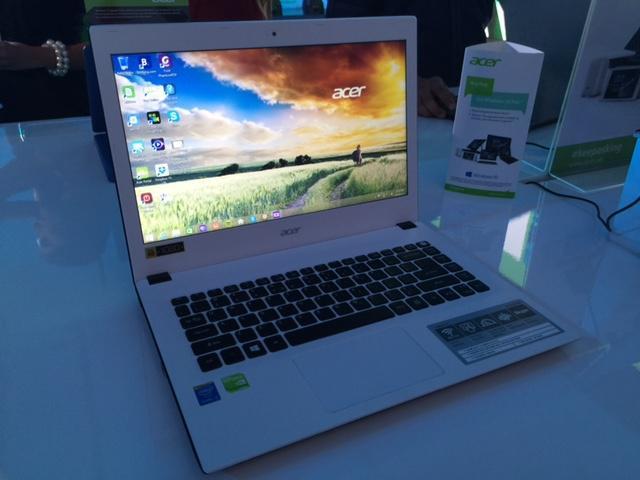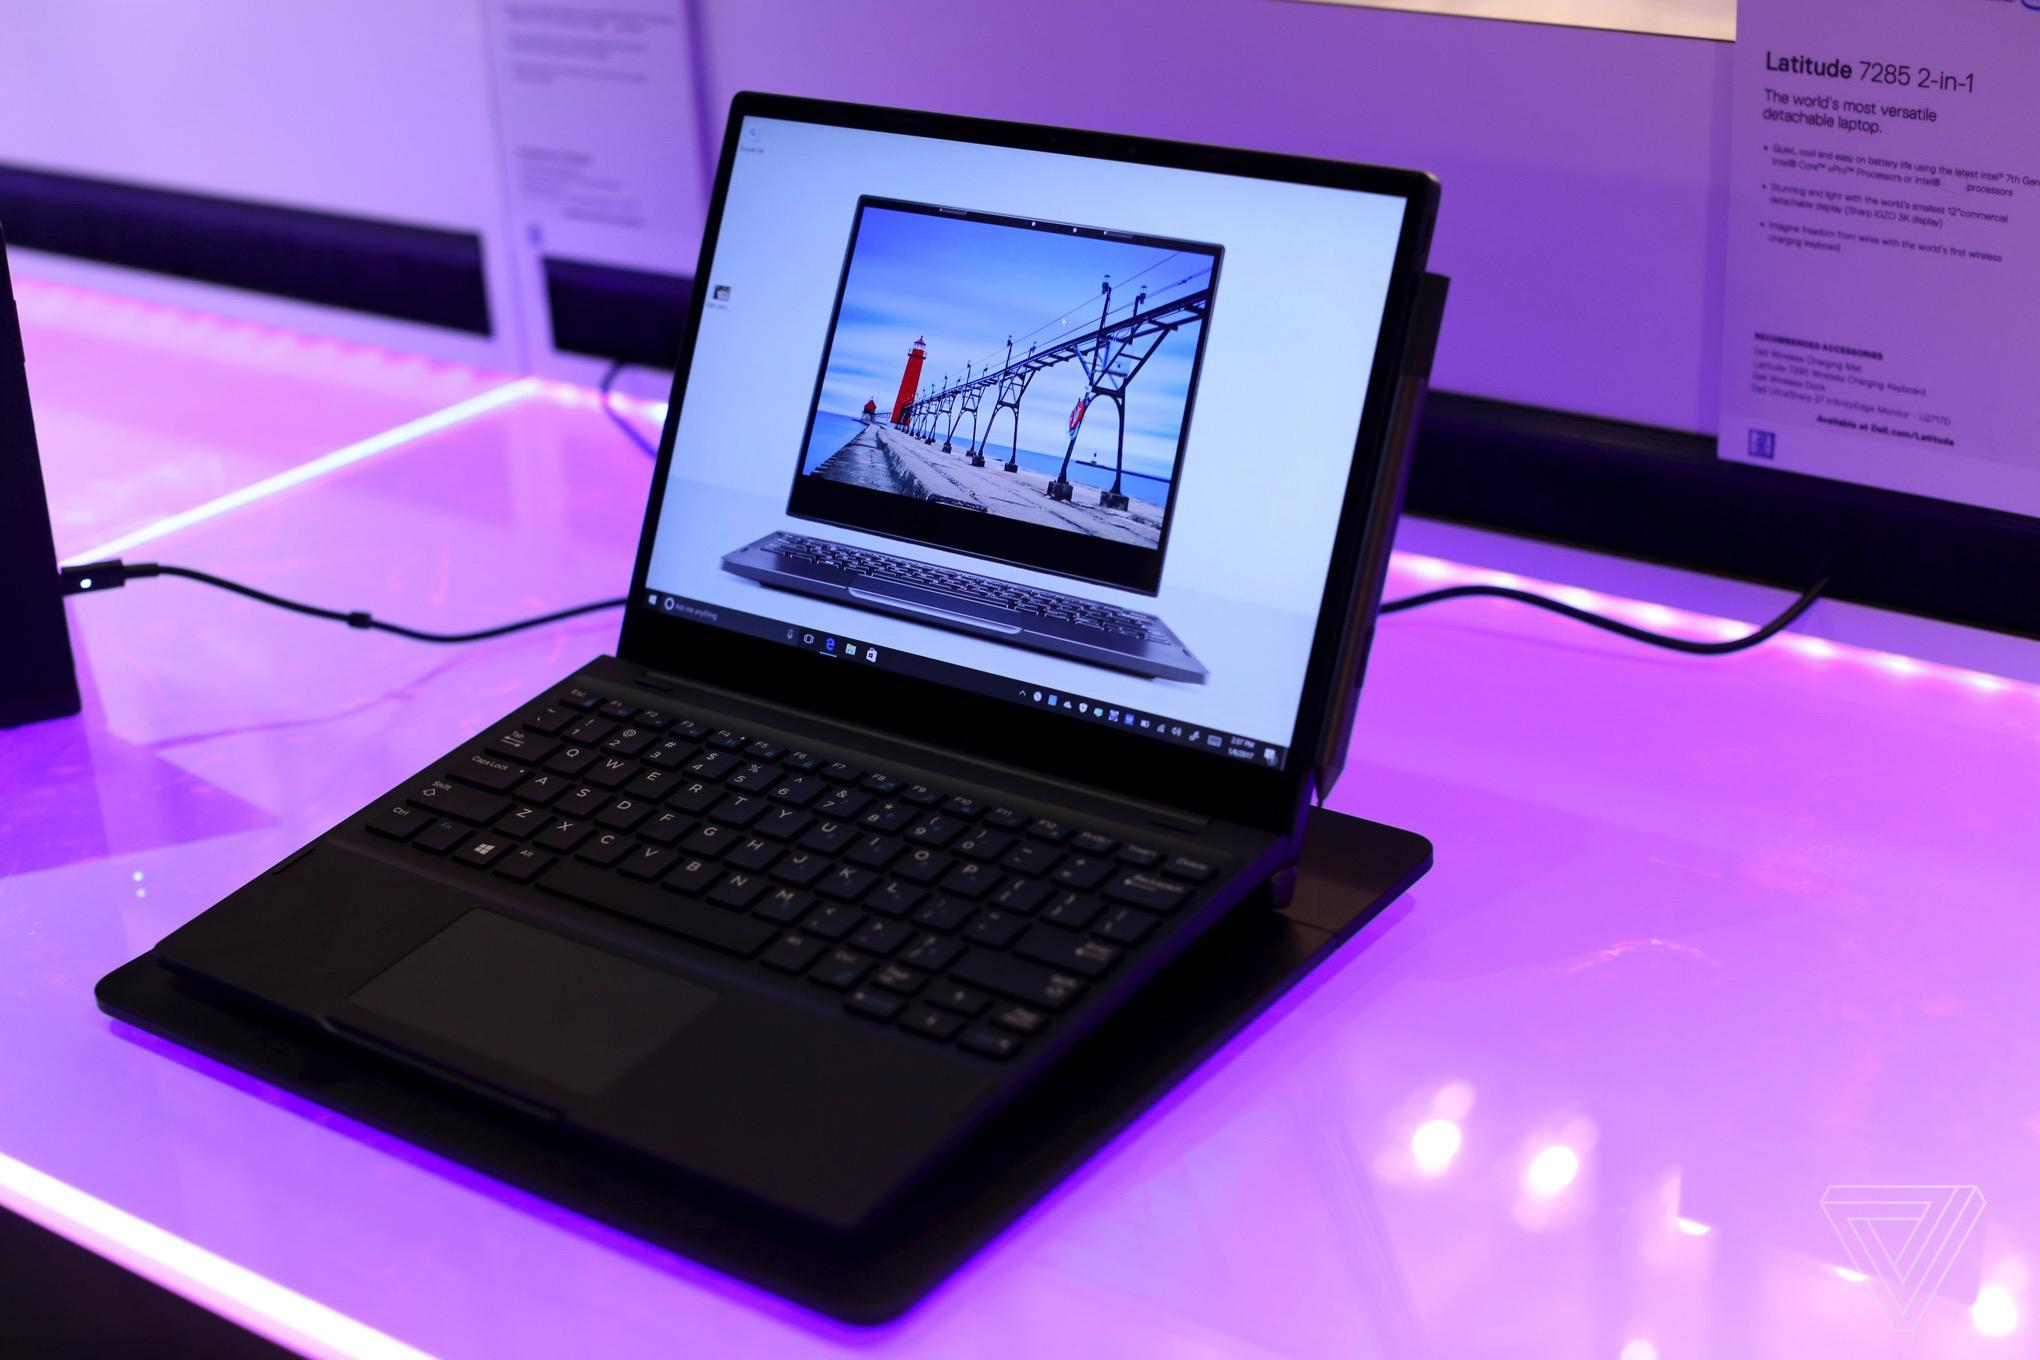The first image is the image on the left, the second image is the image on the right. Evaluate the accuracy of this statement regarding the images: "Two laptops can be seen connected by a crossover cable.". Is it true? Answer yes or no. No. The first image is the image on the left, the second image is the image on the right. For the images shown, is this caption "The top cover of one laptop is visible." true? Answer yes or no. No. 